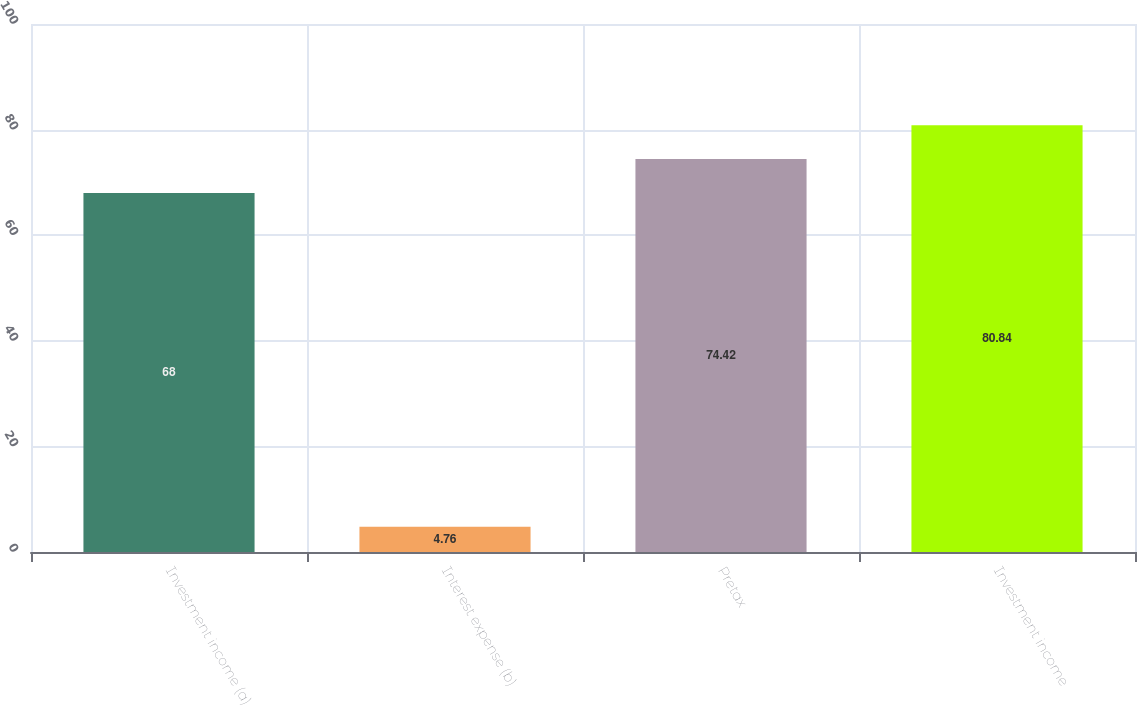Convert chart to OTSL. <chart><loc_0><loc_0><loc_500><loc_500><bar_chart><fcel>Investment income (a)<fcel>Interest expense (b)<fcel>Pretax<fcel>Investment income<nl><fcel>68<fcel>4.76<fcel>74.42<fcel>80.84<nl></chart> 